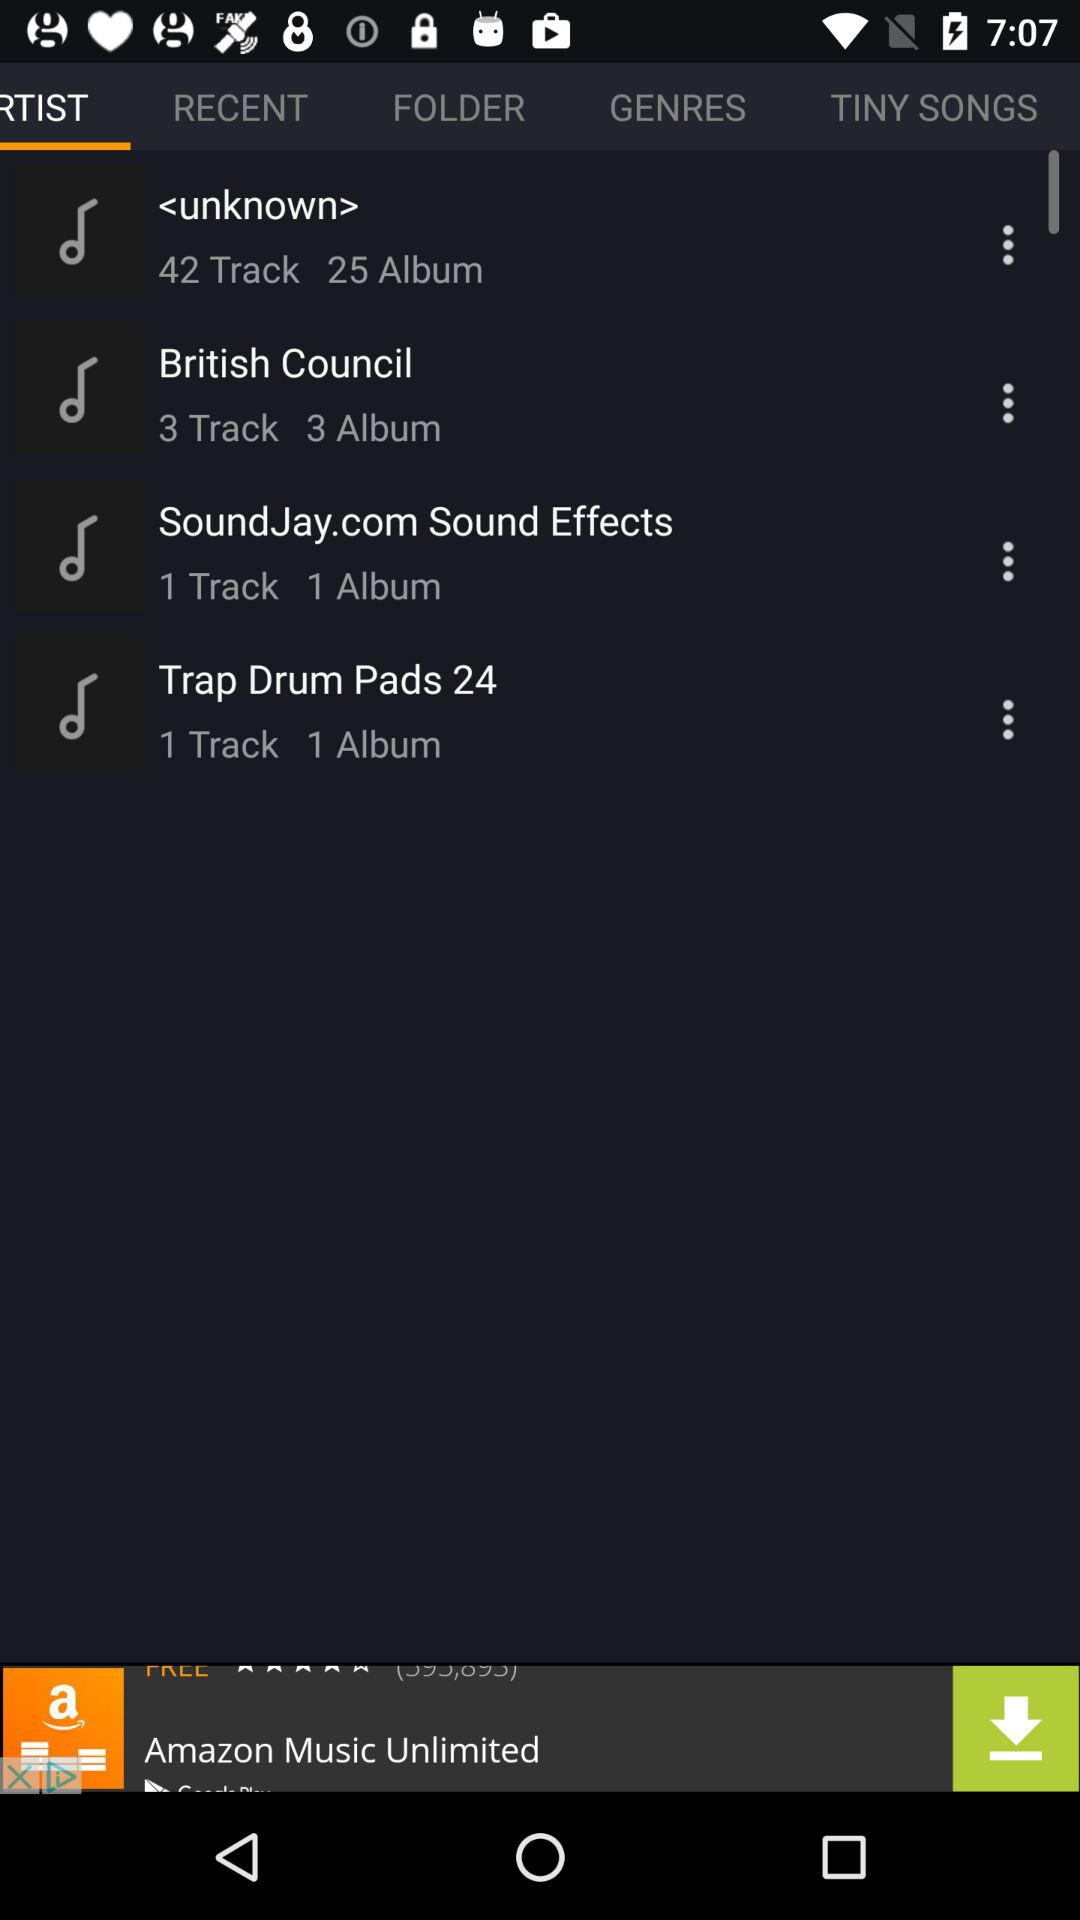How many tracks are in the album 'Trap Drum Pads'?
Answer the question using a single word or phrase. 1 